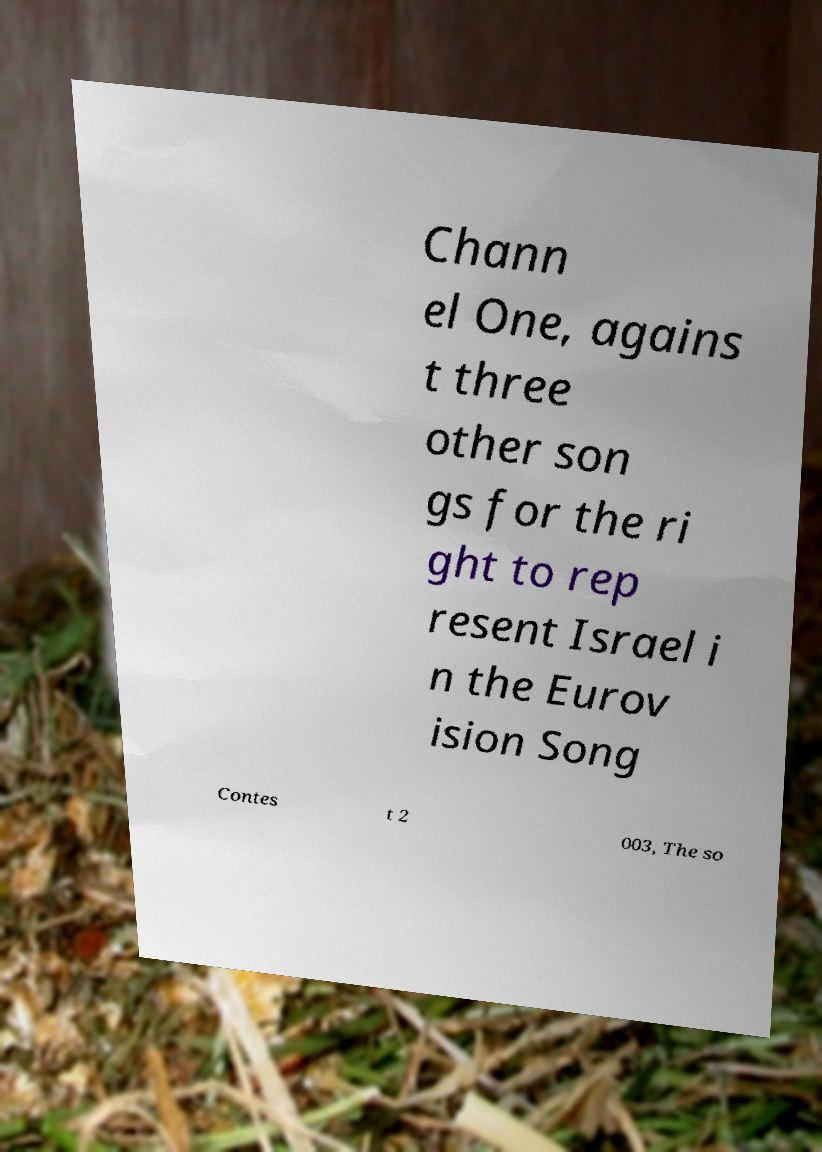Can you read and provide the text displayed in the image?This photo seems to have some interesting text. Can you extract and type it out for me? Chann el One, agains t three other son gs for the ri ght to rep resent Israel i n the Eurov ision Song Contes t 2 003, The so 